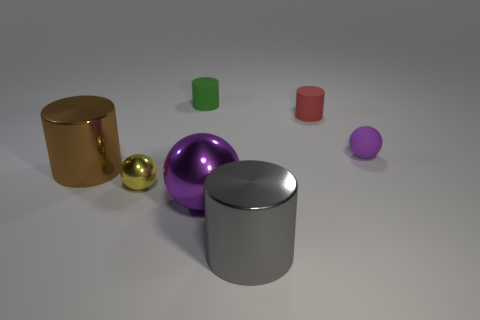The small sphere in front of the tiny ball to the right of the red matte cylinder is what color? yellow 